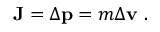Convert formula to latex. <formula><loc_0><loc_0><loc_500><loc_500>J = \Delta p = m \Delta v .</formula> 